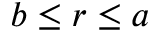Convert formula to latex. <formula><loc_0><loc_0><loc_500><loc_500>b \leq r \leq a</formula> 